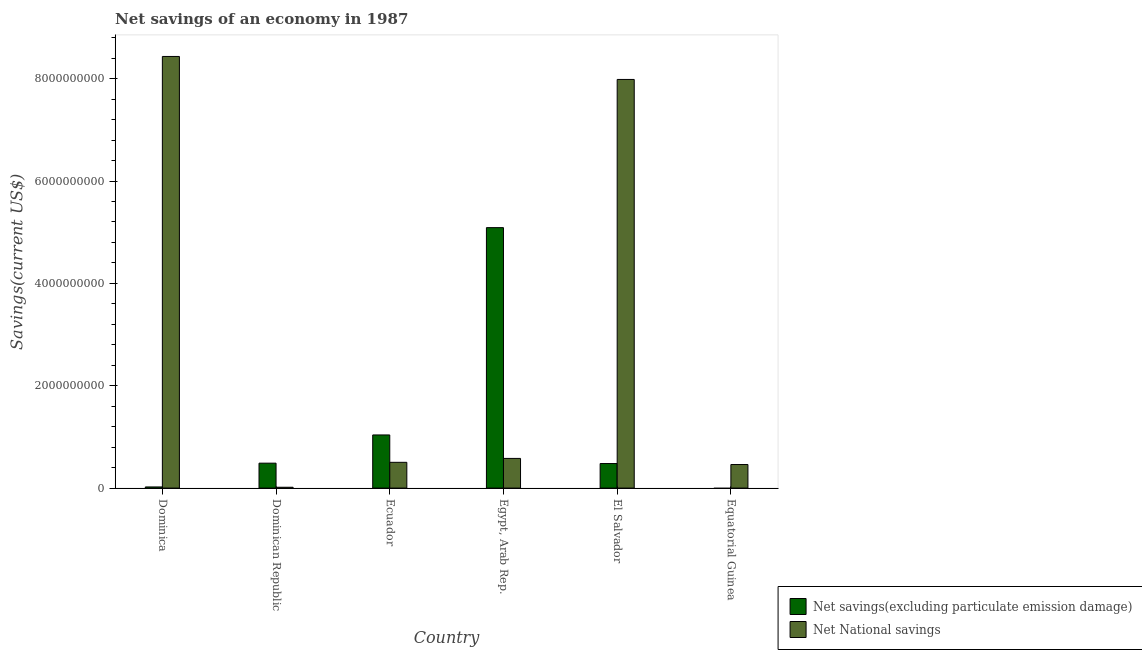How many different coloured bars are there?
Your answer should be very brief. 2. Are the number of bars per tick equal to the number of legend labels?
Offer a terse response. No. How many bars are there on the 2nd tick from the right?
Give a very brief answer. 2. What is the label of the 2nd group of bars from the left?
Your answer should be compact. Dominican Republic. In how many cases, is the number of bars for a given country not equal to the number of legend labels?
Make the answer very short. 1. What is the net national savings in Egypt, Arab Rep.?
Make the answer very short. 5.80e+08. Across all countries, what is the maximum net savings(excluding particulate emission damage)?
Keep it short and to the point. 5.09e+09. Across all countries, what is the minimum net savings(excluding particulate emission damage)?
Keep it short and to the point. 0. In which country was the net national savings maximum?
Offer a very short reply. Dominica. What is the total net national savings in the graph?
Make the answer very short. 1.80e+1. What is the difference between the net national savings in Egypt, Arab Rep. and that in El Salvador?
Your answer should be very brief. -7.41e+09. What is the difference between the net national savings in Dominica and the net savings(excluding particulate emission damage) in Egypt, Arab Rep.?
Offer a very short reply. 3.35e+09. What is the average net savings(excluding particulate emission damage) per country?
Give a very brief answer. 1.19e+09. What is the difference between the net savings(excluding particulate emission damage) and net national savings in Dominican Republic?
Provide a succinct answer. 4.71e+08. What is the ratio of the net national savings in Dominican Republic to that in Ecuador?
Your answer should be very brief. 0.03. Is the net national savings in Dominica less than that in Equatorial Guinea?
Make the answer very short. No. What is the difference between the highest and the second highest net national savings?
Make the answer very short. 4.49e+08. What is the difference between the highest and the lowest net savings(excluding particulate emission damage)?
Ensure brevity in your answer.  5.09e+09. In how many countries, is the net national savings greater than the average net national savings taken over all countries?
Your response must be concise. 2. Is the sum of the net savings(excluding particulate emission damage) in Dominica and Ecuador greater than the maximum net national savings across all countries?
Make the answer very short. No. How many bars are there?
Your answer should be very brief. 11. Does the graph contain any zero values?
Your answer should be very brief. Yes. Does the graph contain grids?
Your response must be concise. No. Where does the legend appear in the graph?
Your response must be concise. Bottom right. How are the legend labels stacked?
Ensure brevity in your answer.  Vertical. What is the title of the graph?
Offer a terse response. Net savings of an economy in 1987. Does "Age 15+" appear as one of the legend labels in the graph?
Give a very brief answer. No. What is the label or title of the X-axis?
Offer a terse response. Country. What is the label or title of the Y-axis?
Offer a terse response. Savings(current US$). What is the Savings(current US$) of Net savings(excluding particulate emission damage) in Dominica?
Your response must be concise. 2.23e+07. What is the Savings(current US$) in Net National savings in Dominica?
Give a very brief answer. 8.43e+09. What is the Savings(current US$) of Net savings(excluding particulate emission damage) in Dominican Republic?
Offer a very short reply. 4.87e+08. What is the Savings(current US$) in Net National savings in Dominican Republic?
Offer a very short reply. 1.63e+07. What is the Savings(current US$) of Net savings(excluding particulate emission damage) in Ecuador?
Keep it short and to the point. 1.04e+09. What is the Savings(current US$) of Net National savings in Ecuador?
Give a very brief answer. 5.04e+08. What is the Savings(current US$) of Net savings(excluding particulate emission damage) in Egypt, Arab Rep.?
Offer a very short reply. 5.09e+09. What is the Savings(current US$) in Net National savings in Egypt, Arab Rep.?
Ensure brevity in your answer.  5.80e+08. What is the Savings(current US$) in Net savings(excluding particulate emission damage) in El Salvador?
Provide a succinct answer. 4.80e+08. What is the Savings(current US$) of Net National savings in El Salvador?
Your response must be concise. 7.99e+09. What is the Savings(current US$) of Net National savings in Equatorial Guinea?
Give a very brief answer. 4.61e+08. Across all countries, what is the maximum Savings(current US$) in Net savings(excluding particulate emission damage)?
Make the answer very short. 5.09e+09. Across all countries, what is the maximum Savings(current US$) in Net National savings?
Offer a very short reply. 8.43e+09. Across all countries, what is the minimum Savings(current US$) of Net National savings?
Your answer should be compact. 1.63e+07. What is the total Savings(current US$) of Net savings(excluding particulate emission damage) in the graph?
Provide a succinct answer. 7.12e+09. What is the total Savings(current US$) in Net National savings in the graph?
Give a very brief answer. 1.80e+1. What is the difference between the Savings(current US$) in Net savings(excluding particulate emission damage) in Dominica and that in Dominican Republic?
Give a very brief answer. -4.65e+08. What is the difference between the Savings(current US$) in Net National savings in Dominica and that in Dominican Republic?
Your answer should be very brief. 8.42e+09. What is the difference between the Savings(current US$) in Net savings(excluding particulate emission damage) in Dominica and that in Ecuador?
Provide a short and direct response. -1.02e+09. What is the difference between the Savings(current US$) in Net National savings in Dominica and that in Ecuador?
Your response must be concise. 7.93e+09. What is the difference between the Savings(current US$) in Net savings(excluding particulate emission damage) in Dominica and that in Egypt, Arab Rep.?
Your answer should be compact. -5.07e+09. What is the difference between the Savings(current US$) in Net National savings in Dominica and that in Egypt, Arab Rep.?
Keep it short and to the point. 7.85e+09. What is the difference between the Savings(current US$) in Net savings(excluding particulate emission damage) in Dominica and that in El Salvador?
Offer a very short reply. -4.57e+08. What is the difference between the Savings(current US$) of Net National savings in Dominica and that in El Salvador?
Make the answer very short. 4.49e+08. What is the difference between the Savings(current US$) in Net National savings in Dominica and that in Equatorial Guinea?
Provide a short and direct response. 7.97e+09. What is the difference between the Savings(current US$) in Net savings(excluding particulate emission damage) in Dominican Republic and that in Ecuador?
Offer a terse response. -5.51e+08. What is the difference between the Savings(current US$) of Net National savings in Dominican Republic and that in Ecuador?
Offer a terse response. -4.87e+08. What is the difference between the Savings(current US$) of Net savings(excluding particulate emission damage) in Dominican Republic and that in Egypt, Arab Rep.?
Ensure brevity in your answer.  -4.60e+09. What is the difference between the Savings(current US$) of Net National savings in Dominican Republic and that in Egypt, Arab Rep.?
Make the answer very short. -5.64e+08. What is the difference between the Savings(current US$) of Net savings(excluding particulate emission damage) in Dominican Republic and that in El Salvador?
Give a very brief answer. 7.37e+06. What is the difference between the Savings(current US$) of Net National savings in Dominican Republic and that in El Salvador?
Your answer should be very brief. -7.97e+09. What is the difference between the Savings(current US$) in Net National savings in Dominican Republic and that in Equatorial Guinea?
Give a very brief answer. -4.44e+08. What is the difference between the Savings(current US$) in Net savings(excluding particulate emission damage) in Ecuador and that in Egypt, Arab Rep.?
Make the answer very short. -4.05e+09. What is the difference between the Savings(current US$) in Net National savings in Ecuador and that in Egypt, Arab Rep.?
Provide a short and direct response. -7.65e+07. What is the difference between the Savings(current US$) of Net savings(excluding particulate emission damage) in Ecuador and that in El Salvador?
Ensure brevity in your answer.  5.59e+08. What is the difference between the Savings(current US$) in Net National savings in Ecuador and that in El Salvador?
Offer a very short reply. -7.48e+09. What is the difference between the Savings(current US$) in Net National savings in Ecuador and that in Equatorial Guinea?
Keep it short and to the point. 4.29e+07. What is the difference between the Savings(current US$) of Net savings(excluding particulate emission damage) in Egypt, Arab Rep. and that in El Salvador?
Provide a short and direct response. 4.61e+09. What is the difference between the Savings(current US$) in Net National savings in Egypt, Arab Rep. and that in El Salvador?
Your answer should be very brief. -7.41e+09. What is the difference between the Savings(current US$) of Net National savings in Egypt, Arab Rep. and that in Equatorial Guinea?
Make the answer very short. 1.19e+08. What is the difference between the Savings(current US$) in Net National savings in El Salvador and that in Equatorial Guinea?
Make the answer very short. 7.52e+09. What is the difference between the Savings(current US$) in Net savings(excluding particulate emission damage) in Dominica and the Savings(current US$) in Net National savings in Dominican Republic?
Give a very brief answer. 6.06e+06. What is the difference between the Savings(current US$) of Net savings(excluding particulate emission damage) in Dominica and the Savings(current US$) of Net National savings in Ecuador?
Your answer should be compact. -4.81e+08. What is the difference between the Savings(current US$) of Net savings(excluding particulate emission damage) in Dominica and the Savings(current US$) of Net National savings in Egypt, Arab Rep.?
Provide a succinct answer. -5.58e+08. What is the difference between the Savings(current US$) of Net savings(excluding particulate emission damage) in Dominica and the Savings(current US$) of Net National savings in El Salvador?
Provide a succinct answer. -7.96e+09. What is the difference between the Savings(current US$) of Net savings(excluding particulate emission damage) in Dominica and the Savings(current US$) of Net National savings in Equatorial Guinea?
Your answer should be very brief. -4.38e+08. What is the difference between the Savings(current US$) of Net savings(excluding particulate emission damage) in Dominican Republic and the Savings(current US$) of Net National savings in Ecuador?
Your answer should be compact. -1.63e+07. What is the difference between the Savings(current US$) of Net savings(excluding particulate emission damage) in Dominican Republic and the Savings(current US$) of Net National savings in Egypt, Arab Rep.?
Your response must be concise. -9.28e+07. What is the difference between the Savings(current US$) in Net savings(excluding particulate emission damage) in Dominican Republic and the Savings(current US$) in Net National savings in El Salvador?
Offer a terse response. -7.50e+09. What is the difference between the Savings(current US$) in Net savings(excluding particulate emission damage) in Dominican Republic and the Savings(current US$) in Net National savings in Equatorial Guinea?
Your answer should be compact. 2.66e+07. What is the difference between the Savings(current US$) in Net savings(excluding particulate emission damage) in Ecuador and the Savings(current US$) in Net National savings in Egypt, Arab Rep.?
Provide a succinct answer. 4.58e+08. What is the difference between the Savings(current US$) of Net savings(excluding particulate emission damage) in Ecuador and the Savings(current US$) of Net National savings in El Salvador?
Offer a terse response. -6.95e+09. What is the difference between the Savings(current US$) of Net savings(excluding particulate emission damage) in Ecuador and the Savings(current US$) of Net National savings in Equatorial Guinea?
Provide a succinct answer. 5.78e+08. What is the difference between the Savings(current US$) of Net savings(excluding particulate emission damage) in Egypt, Arab Rep. and the Savings(current US$) of Net National savings in El Salvador?
Ensure brevity in your answer.  -2.90e+09. What is the difference between the Savings(current US$) of Net savings(excluding particulate emission damage) in Egypt, Arab Rep. and the Savings(current US$) of Net National savings in Equatorial Guinea?
Offer a very short reply. 4.63e+09. What is the difference between the Savings(current US$) in Net savings(excluding particulate emission damage) in El Salvador and the Savings(current US$) in Net National savings in Equatorial Guinea?
Your response must be concise. 1.92e+07. What is the average Savings(current US$) in Net savings(excluding particulate emission damage) per country?
Your answer should be compact. 1.19e+09. What is the average Savings(current US$) in Net National savings per country?
Offer a terse response. 3.00e+09. What is the difference between the Savings(current US$) in Net savings(excluding particulate emission damage) and Savings(current US$) in Net National savings in Dominica?
Offer a terse response. -8.41e+09. What is the difference between the Savings(current US$) in Net savings(excluding particulate emission damage) and Savings(current US$) in Net National savings in Dominican Republic?
Give a very brief answer. 4.71e+08. What is the difference between the Savings(current US$) of Net savings(excluding particulate emission damage) and Savings(current US$) of Net National savings in Ecuador?
Offer a terse response. 5.35e+08. What is the difference between the Savings(current US$) of Net savings(excluding particulate emission damage) and Savings(current US$) of Net National savings in Egypt, Arab Rep.?
Your answer should be very brief. 4.51e+09. What is the difference between the Savings(current US$) of Net savings(excluding particulate emission damage) and Savings(current US$) of Net National savings in El Salvador?
Offer a very short reply. -7.51e+09. What is the ratio of the Savings(current US$) in Net savings(excluding particulate emission damage) in Dominica to that in Dominican Republic?
Your response must be concise. 0.05. What is the ratio of the Savings(current US$) of Net National savings in Dominica to that in Dominican Republic?
Your answer should be very brief. 518.02. What is the ratio of the Savings(current US$) in Net savings(excluding particulate emission damage) in Dominica to that in Ecuador?
Offer a very short reply. 0.02. What is the ratio of the Savings(current US$) of Net National savings in Dominica to that in Ecuador?
Keep it short and to the point. 16.75. What is the ratio of the Savings(current US$) of Net savings(excluding particulate emission damage) in Dominica to that in Egypt, Arab Rep.?
Your response must be concise. 0. What is the ratio of the Savings(current US$) of Net National savings in Dominica to that in Egypt, Arab Rep.?
Ensure brevity in your answer.  14.54. What is the ratio of the Savings(current US$) in Net savings(excluding particulate emission damage) in Dominica to that in El Salvador?
Offer a very short reply. 0.05. What is the ratio of the Savings(current US$) of Net National savings in Dominica to that in El Salvador?
Your answer should be compact. 1.06. What is the ratio of the Savings(current US$) in Net National savings in Dominica to that in Equatorial Guinea?
Your answer should be compact. 18.31. What is the ratio of the Savings(current US$) of Net savings(excluding particulate emission damage) in Dominican Republic to that in Ecuador?
Keep it short and to the point. 0.47. What is the ratio of the Savings(current US$) of Net National savings in Dominican Republic to that in Ecuador?
Provide a short and direct response. 0.03. What is the ratio of the Savings(current US$) of Net savings(excluding particulate emission damage) in Dominican Republic to that in Egypt, Arab Rep.?
Keep it short and to the point. 0.1. What is the ratio of the Savings(current US$) in Net National savings in Dominican Republic to that in Egypt, Arab Rep.?
Provide a short and direct response. 0.03. What is the ratio of the Savings(current US$) of Net savings(excluding particulate emission damage) in Dominican Republic to that in El Salvador?
Your answer should be very brief. 1.02. What is the ratio of the Savings(current US$) of Net National savings in Dominican Republic to that in El Salvador?
Make the answer very short. 0. What is the ratio of the Savings(current US$) of Net National savings in Dominican Republic to that in Equatorial Guinea?
Offer a very short reply. 0.04. What is the ratio of the Savings(current US$) in Net savings(excluding particulate emission damage) in Ecuador to that in Egypt, Arab Rep.?
Give a very brief answer. 0.2. What is the ratio of the Savings(current US$) in Net National savings in Ecuador to that in Egypt, Arab Rep.?
Provide a succinct answer. 0.87. What is the ratio of the Savings(current US$) of Net savings(excluding particulate emission damage) in Ecuador to that in El Salvador?
Provide a succinct answer. 2.16. What is the ratio of the Savings(current US$) of Net National savings in Ecuador to that in El Salvador?
Give a very brief answer. 0.06. What is the ratio of the Savings(current US$) in Net National savings in Ecuador to that in Equatorial Guinea?
Provide a short and direct response. 1.09. What is the ratio of the Savings(current US$) of Net savings(excluding particulate emission damage) in Egypt, Arab Rep. to that in El Salvador?
Offer a very short reply. 10.61. What is the ratio of the Savings(current US$) in Net National savings in Egypt, Arab Rep. to that in El Salvador?
Your answer should be very brief. 0.07. What is the ratio of the Savings(current US$) in Net National savings in Egypt, Arab Rep. to that in Equatorial Guinea?
Offer a terse response. 1.26. What is the ratio of the Savings(current US$) in Net National savings in El Salvador to that in Equatorial Guinea?
Offer a very short reply. 17.34. What is the difference between the highest and the second highest Savings(current US$) of Net savings(excluding particulate emission damage)?
Provide a succinct answer. 4.05e+09. What is the difference between the highest and the second highest Savings(current US$) in Net National savings?
Your answer should be compact. 4.49e+08. What is the difference between the highest and the lowest Savings(current US$) in Net savings(excluding particulate emission damage)?
Your answer should be compact. 5.09e+09. What is the difference between the highest and the lowest Savings(current US$) of Net National savings?
Make the answer very short. 8.42e+09. 